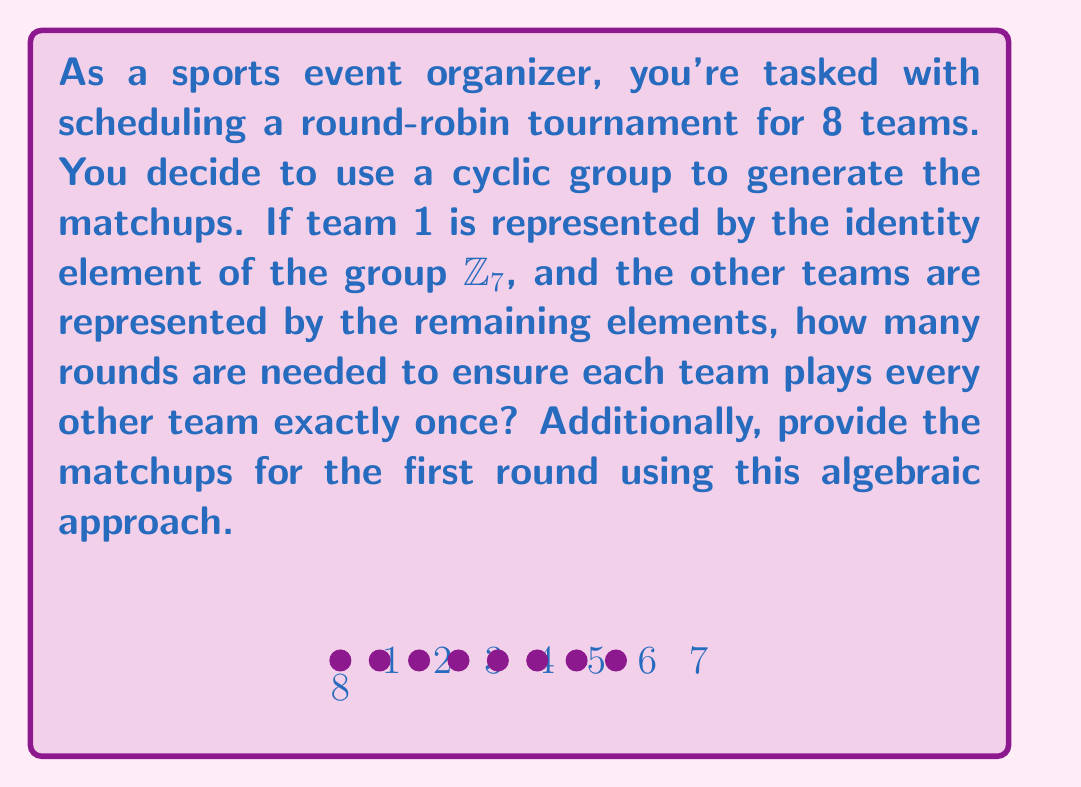What is the answer to this math problem? Let's approach this step-by-step:

1) In a round-robin tournament, each team must play every other team once. With 8 teams, each team needs to play 7 games.

2) We're using the cyclic group $\mathbb{Z}_7$ to represent 7 of the teams, with the 8th team represented separately. This is because $\mathbb{Z}_7$ has 7 elements (0, 1, 2, 3, 4, 5, 6), which we'll map to teams 1 through 7.

3) In group theory, we can generate matchups by adding a constant to each element of the group (modulo 7). This constant will change for each round.

4) For the first round, we can pair team 8 with team 1 (represented by 0 in $\mathbb{Z}_7$), and then pair the remaining teams based on their position in the group:
   (0,1), (2,6), (3,5), (4,4)
   
   Converting back to team numbers:
   (8,1), (3,7), (4,6), (5,5)

5) For subsequent rounds, we add 1 to each element (modulo 7) and repeat the pairing process. This ensures that each team plays every other team exactly once.

6) Since there are 7 elements in $\mathbb{Z}_7$, this process will generate 7 unique rounds before repeating.

Therefore, 7 rounds are needed to complete the tournament, ensuring each team plays every other team exactly once.
Answer: 7 rounds; First round matchups: (8,1), (3,7), (4,6), (5,5) 